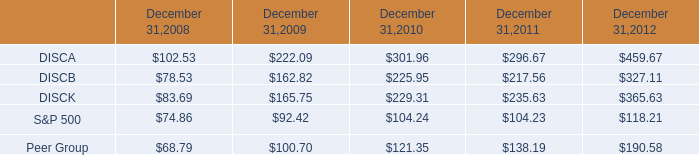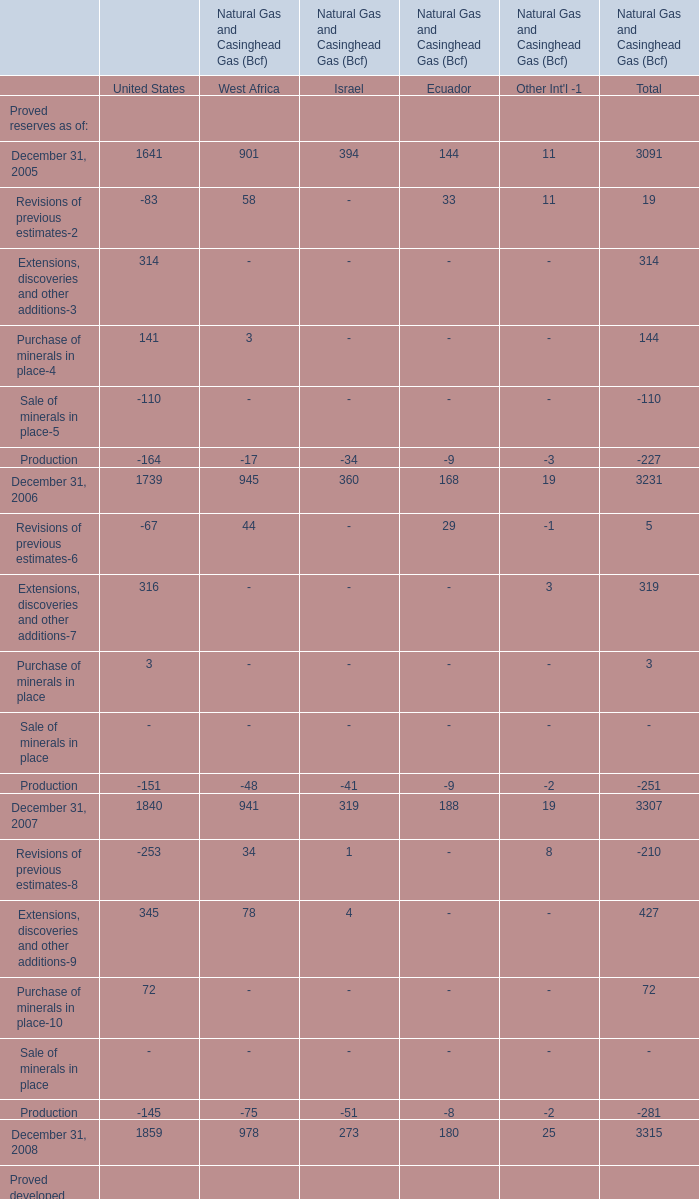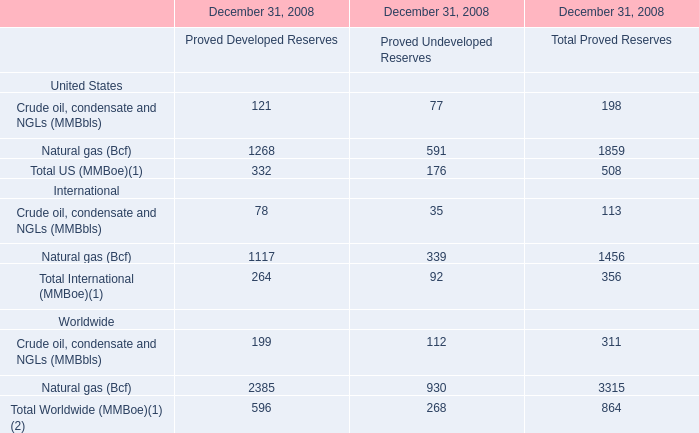what was the percentage cumulative total shareholder return on disca common stock from september 18 , 2008 to december 31 , 2012? 
Computations: ((459.67 - 100) / 100)
Answer: 3.5967. 